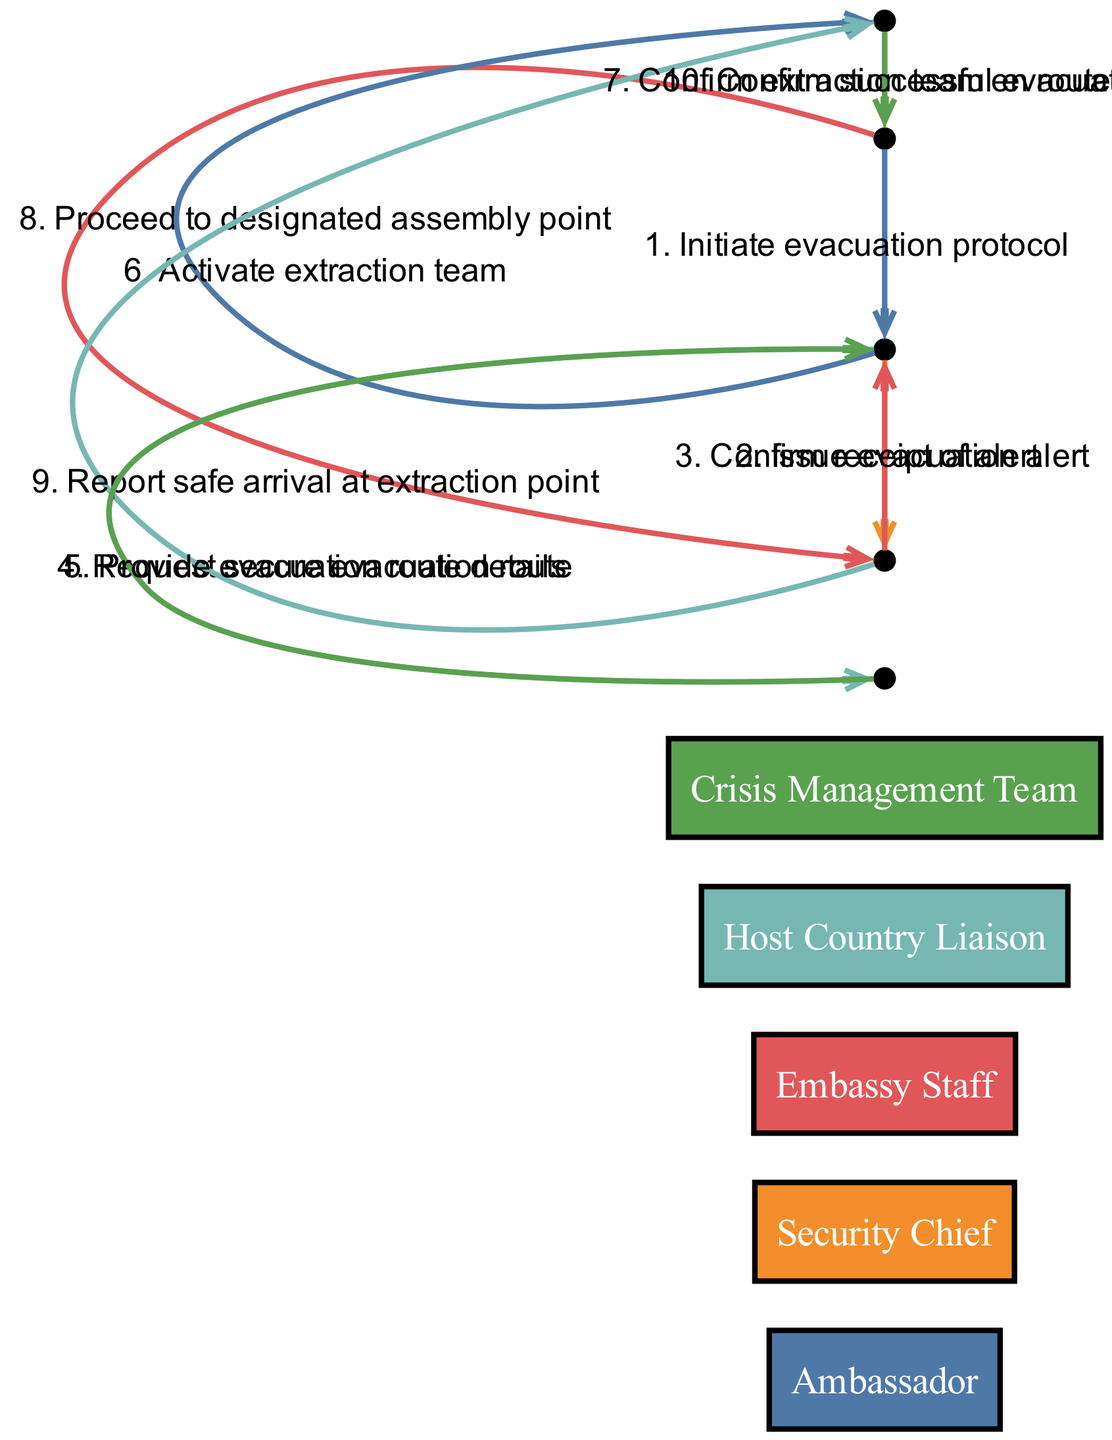What is the first action initiated in the diagram? The first action in the diagram is "Initiate evacuation protocol," which is triggered by the Ambassador signaling the Security Chief.
Answer: Initiate evacuation protocol How many actors are involved in the evacuation protocol? There are five actors listed in the diagram: Ambassador, Security Chief, Embassy Staff, Host Country Liaison, and Crisis Management Team.
Answer: Five Which actor confirms the successful evacuation? The Crisis Management Team is the actor that confirms the successful evacuation to the Ambassador.
Answer: Crisis Management Team What is the relationship between the Security Chief and the Embassy Staff in the evacuation process? The Security Chief issues an evacuation alert to the Embassy Staff, and the Embassy Staff responds by confirming receipt of that alert, indicating a direct communication loop between the two.
Answer: Communication loop How many actions occur between the Security Chief and the Crisis Management Team? There are three actions that occur between the Security Chief and the Crisis Management Team, including activating the extraction team, confirming the extraction team is en route, and confirming successful evacuation.
Answer: Three What is the last action taken in the sequence? The last action taken in the sequence is "Confirm successful evacuation," which is communicated from the Crisis Management Team to the Ambassador.
Answer: Confirm successful evacuation At what point do the Embassy Staff report their safe arrival? The Embassy Staff report their safe arrival at the extraction point after proceeding to the designated assembly point, indicating two key steps in the process before this report.
Answer: After proceeding to designated assembly point Which role is responsible for requesting secure evacuation route? The Security Chief is responsible for requesting the secure evacuation route from the Host Country Liaison.
Answer: Security Chief What does the Host Country Liaison provide in response to the Security Chief's request? In response to the Security Chief's request, the Host Country Liaison provides the evacuation route details, which are vital for the evacuation process.
Answer: Provide evacuation route details 